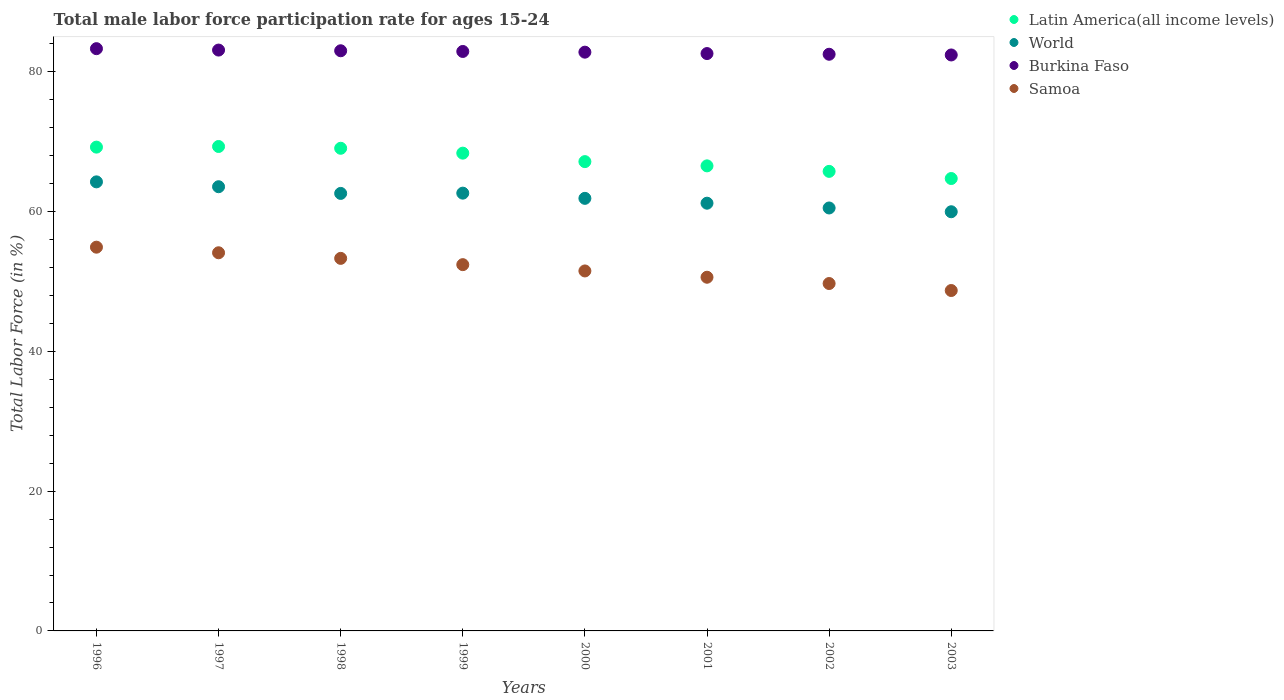How many different coloured dotlines are there?
Make the answer very short. 4. Is the number of dotlines equal to the number of legend labels?
Ensure brevity in your answer.  Yes. What is the male labor force participation rate in Burkina Faso in 2002?
Ensure brevity in your answer.  82.5. Across all years, what is the maximum male labor force participation rate in World?
Provide a succinct answer. 64.24. Across all years, what is the minimum male labor force participation rate in Samoa?
Provide a short and direct response. 48.7. In which year was the male labor force participation rate in World minimum?
Keep it short and to the point. 2003. What is the total male labor force participation rate in Latin America(all income levels) in the graph?
Ensure brevity in your answer.  540.06. What is the difference between the male labor force participation rate in World in 1999 and that in 2002?
Make the answer very short. 2.12. What is the difference between the male labor force participation rate in Samoa in 1997 and the male labor force participation rate in Latin America(all income levels) in 1999?
Offer a very short reply. -14.25. What is the average male labor force participation rate in World per year?
Your answer should be very brief. 62.07. In the year 2003, what is the difference between the male labor force participation rate in Burkina Faso and male labor force participation rate in World?
Offer a very short reply. 22.43. In how many years, is the male labor force participation rate in Burkina Faso greater than 80 %?
Ensure brevity in your answer.  8. What is the ratio of the male labor force participation rate in Burkina Faso in 1999 to that in 2001?
Make the answer very short. 1. Is the male labor force participation rate in World in 1996 less than that in 1997?
Ensure brevity in your answer.  No. What is the difference between the highest and the second highest male labor force participation rate in Burkina Faso?
Your response must be concise. 0.2. What is the difference between the highest and the lowest male labor force participation rate in Samoa?
Provide a succinct answer. 6.2. In how many years, is the male labor force participation rate in Burkina Faso greater than the average male labor force participation rate in Burkina Faso taken over all years?
Give a very brief answer. 4. Is the sum of the male labor force participation rate in Samoa in 1997 and 1999 greater than the maximum male labor force participation rate in Latin America(all income levels) across all years?
Offer a very short reply. Yes. Does the male labor force participation rate in Latin America(all income levels) monotonically increase over the years?
Offer a terse response. No. Is the male labor force participation rate in Latin America(all income levels) strictly greater than the male labor force participation rate in World over the years?
Your answer should be compact. Yes. How many dotlines are there?
Your answer should be very brief. 4. How many years are there in the graph?
Your answer should be compact. 8. Does the graph contain grids?
Offer a terse response. No. Where does the legend appear in the graph?
Your answer should be very brief. Top right. How many legend labels are there?
Offer a very short reply. 4. What is the title of the graph?
Offer a very short reply. Total male labor force participation rate for ages 15-24. Does "French Polynesia" appear as one of the legend labels in the graph?
Your answer should be compact. No. What is the label or title of the X-axis?
Offer a very short reply. Years. What is the Total Labor Force (in %) in Latin America(all income levels) in 1996?
Your answer should be compact. 69.21. What is the Total Labor Force (in %) of World in 1996?
Provide a short and direct response. 64.24. What is the Total Labor Force (in %) of Burkina Faso in 1996?
Offer a terse response. 83.3. What is the Total Labor Force (in %) in Samoa in 1996?
Offer a very short reply. 54.9. What is the Total Labor Force (in %) of Latin America(all income levels) in 1997?
Give a very brief answer. 69.31. What is the Total Labor Force (in %) in World in 1997?
Provide a short and direct response. 63.55. What is the Total Labor Force (in %) in Burkina Faso in 1997?
Give a very brief answer. 83.1. What is the Total Labor Force (in %) of Samoa in 1997?
Offer a very short reply. 54.1. What is the Total Labor Force (in %) in Latin America(all income levels) in 1998?
Give a very brief answer. 69.05. What is the Total Labor Force (in %) of World in 1998?
Offer a terse response. 62.59. What is the Total Labor Force (in %) of Samoa in 1998?
Provide a succinct answer. 53.3. What is the Total Labor Force (in %) of Latin America(all income levels) in 1999?
Make the answer very short. 68.35. What is the Total Labor Force (in %) in World in 1999?
Keep it short and to the point. 62.63. What is the Total Labor Force (in %) in Burkina Faso in 1999?
Your response must be concise. 82.9. What is the Total Labor Force (in %) of Samoa in 1999?
Give a very brief answer. 52.4. What is the Total Labor Force (in %) in Latin America(all income levels) in 2000?
Make the answer very short. 67.14. What is the Total Labor Force (in %) in World in 2000?
Your answer should be compact. 61.89. What is the Total Labor Force (in %) in Burkina Faso in 2000?
Keep it short and to the point. 82.8. What is the Total Labor Force (in %) of Samoa in 2000?
Your answer should be compact. 51.5. What is the Total Labor Force (in %) of Latin America(all income levels) in 2001?
Your answer should be compact. 66.53. What is the Total Labor Force (in %) of World in 2001?
Give a very brief answer. 61.19. What is the Total Labor Force (in %) in Burkina Faso in 2001?
Your response must be concise. 82.6. What is the Total Labor Force (in %) of Samoa in 2001?
Offer a very short reply. 50.6. What is the Total Labor Force (in %) in Latin America(all income levels) in 2002?
Your answer should be very brief. 65.75. What is the Total Labor Force (in %) of World in 2002?
Your response must be concise. 60.51. What is the Total Labor Force (in %) of Burkina Faso in 2002?
Your answer should be very brief. 82.5. What is the Total Labor Force (in %) of Samoa in 2002?
Your response must be concise. 49.7. What is the Total Labor Force (in %) of Latin America(all income levels) in 2003?
Keep it short and to the point. 64.72. What is the Total Labor Force (in %) of World in 2003?
Your answer should be compact. 59.97. What is the Total Labor Force (in %) in Burkina Faso in 2003?
Your answer should be very brief. 82.4. What is the Total Labor Force (in %) in Samoa in 2003?
Offer a terse response. 48.7. Across all years, what is the maximum Total Labor Force (in %) in Latin America(all income levels)?
Your response must be concise. 69.31. Across all years, what is the maximum Total Labor Force (in %) of World?
Your answer should be very brief. 64.24. Across all years, what is the maximum Total Labor Force (in %) in Burkina Faso?
Provide a short and direct response. 83.3. Across all years, what is the maximum Total Labor Force (in %) of Samoa?
Give a very brief answer. 54.9. Across all years, what is the minimum Total Labor Force (in %) in Latin America(all income levels)?
Give a very brief answer. 64.72. Across all years, what is the minimum Total Labor Force (in %) of World?
Provide a succinct answer. 59.97. Across all years, what is the minimum Total Labor Force (in %) in Burkina Faso?
Provide a succinct answer. 82.4. Across all years, what is the minimum Total Labor Force (in %) in Samoa?
Provide a succinct answer. 48.7. What is the total Total Labor Force (in %) in Latin America(all income levels) in the graph?
Give a very brief answer. 540.06. What is the total Total Labor Force (in %) of World in the graph?
Offer a terse response. 496.57. What is the total Total Labor Force (in %) in Burkina Faso in the graph?
Your response must be concise. 662.6. What is the total Total Labor Force (in %) in Samoa in the graph?
Make the answer very short. 415.2. What is the difference between the Total Labor Force (in %) in Latin America(all income levels) in 1996 and that in 1997?
Your answer should be very brief. -0.09. What is the difference between the Total Labor Force (in %) of World in 1996 and that in 1997?
Ensure brevity in your answer.  0.7. What is the difference between the Total Labor Force (in %) in Latin America(all income levels) in 1996 and that in 1998?
Keep it short and to the point. 0.16. What is the difference between the Total Labor Force (in %) of World in 1996 and that in 1998?
Offer a terse response. 1.65. What is the difference between the Total Labor Force (in %) of Latin America(all income levels) in 1996 and that in 1999?
Keep it short and to the point. 0.86. What is the difference between the Total Labor Force (in %) of World in 1996 and that in 1999?
Provide a short and direct response. 1.62. What is the difference between the Total Labor Force (in %) in Burkina Faso in 1996 and that in 1999?
Offer a very short reply. 0.4. What is the difference between the Total Labor Force (in %) in Samoa in 1996 and that in 1999?
Your answer should be compact. 2.5. What is the difference between the Total Labor Force (in %) in Latin America(all income levels) in 1996 and that in 2000?
Give a very brief answer. 2.07. What is the difference between the Total Labor Force (in %) in World in 1996 and that in 2000?
Your answer should be very brief. 2.36. What is the difference between the Total Labor Force (in %) in Burkina Faso in 1996 and that in 2000?
Your answer should be very brief. 0.5. What is the difference between the Total Labor Force (in %) in Samoa in 1996 and that in 2000?
Provide a succinct answer. 3.4. What is the difference between the Total Labor Force (in %) of Latin America(all income levels) in 1996 and that in 2001?
Your answer should be compact. 2.68. What is the difference between the Total Labor Force (in %) of World in 1996 and that in 2001?
Offer a terse response. 3.05. What is the difference between the Total Labor Force (in %) in Burkina Faso in 1996 and that in 2001?
Keep it short and to the point. 0.7. What is the difference between the Total Labor Force (in %) of Samoa in 1996 and that in 2001?
Offer a very short reply. 4.3. What is the difference between the Total Labor Force (in %) of Latin America(all income levels) in 1996 and that in 2002?
Offer a terse response. 3.47. What is the difference between the Total Labor Force (in %) in World in 1996 and that in 2002?
Give a very brief answer. 3.74. What is the difference between the Total Labor Force (in %) in Latin America(all income levels) in 1996 and that in 2003?
Ensure brevity in your answer.  4.49. What is the difference between the Total Labor Force (in %) in World in 1996 and that in 2003?
Provide a succinct answer. 4.28. What is the difference between the Total Labor Force (in %) of Burkina Faso in 1996 and that in 2003?
Your response must be concise. 0.9. What is the difference between the Total Labor Force (in %) of Latin America(all income levels) in 1997 and that in 1998?
Offer a very short reply. 0.26. What is the difference between the Total Labor Force (in %) of World in 1997 and that in 1998?
Make the answer very short. 0.96. What is the difference between the Total Labor Force (in %) in Burkina Faso in 1997 and that in 1998?
Keep it short and to the point. 0.1. What is the difference between the Total Labor Force (in %) of Samoa in 1997 and that in 1998?
Offer a very short reply. 0.8. What is the difference between the Total Labor Force (in %) in Latin America(all income levels) in 1997 and that in 1999?
Your answer should be very brief. 0.95. What is the difference between the Total Labor Force (in %) of World in 1997 and that in 1999?
Your answer should be compact. 0.92. What is the difference between the Total Labor Force (in %) in Burkina Faso in 1997 and that in 1999?
Provide a succinct answer. 0.2. What is the difference between the Total Labor Force (in %) of Samoa in 1997 and that in 1999?
Your response must be concise. 1.7. What is the difference between the Total Labor Force (in %) of Latin America(all income levels) in 1997 and that in 2000?
Offer a terse response. 2.16. What is the difference between the Total Labor Force (in %) of World in 1997 and that in 2000?
Provide a succinct answer. 1.66. What is the difference between the Total Labor Force (in %) in Burkina Faso in 1997 and that in 2000?
Give a very brief answer. 0.3. What is the difference between the Total Labor Force (in %) of Samoa in 1997 and that in 2000?
Your response must be concise. 2.6. What is the difference between the Total Labor Force (in %) in Latin America(all income levels) in 1997 and that in 2001?
Provide a short and direct response. 2.77. What is the difference between the Total Labor Force (in %) in World in 1997 and that in 2001?
Ensure brevity in your answer.  2.36. What is the difference between the Total Labor Force (in %) of Burkina Faso in 1997 and that in 2001?
Make the answer very short. 0.5. What is the difference between the Total Labor Force (in %) of Latin America(all income levels) in 1997 and that in 2002?
Ensure brevity in your answer.  3.56. What is the difference between the Total Labor Force (in %) of World in 1997 and that in 2002?
Provide a short and direct response. 3.04. What is the difference between the Total Labor Force (in %) of Samoa in 1997 and that in 2002?
Offer a very short reply. 4.4. What is the difference between the Total Labor Force (in %) of Latin America(all income levels) in 1997 and that in 2003?
Provide a short and direct response. 4.58. What is the difference between the Total Labor Force (in %) in World in 1997 and that in 2003?
Your response must be concise. 3.58. What is the difference between the Total Labor Force (in %) in Burkina Faso in 1997 and that in 2003?
Your answer should be compact. 0.7. What is the difference between the Total Labor Force (in %) of Samoa in 1997 and that in 2003?
Your answer should be compact. 5.4. What is the difference between the Total Labor Force (in %) in Latin America(all income levels) in 1998 and that in 1999?
Offer a very short reply. 0.7. What is the difference between the Total Labor Force (in %) of World in 1998 and that in 1999?
Ensure brevity in your answer.  -0.04. What is the difference between the Total Labor Force (in %) of Latin America(all income levels) in 1998 and that in 2000?
Make the answer very short. 1.91. What is the difference between the Total Labor Force (in %) of World in 1998 and that in 2000?
Your response must be concise. 0.71. What is the difference between the Total Labor Force (in %) of Latin America(all income levels) in 1998 and that in 2001?
Your answer should be compact. 2.52. What is the difference between the Total Labor Force (in %) of World in 1998 and that in 2001?
Provide a short and direct response. 1.4. What is the difference between the Total Labor Force (in %) in Samoa in 1998 and that in 2001?
Give a very brief answer. 2.7. What is the difference between the Total Labor Force (in %) in Latin America(all income levels) in 1998 and that in 2002?
Your answer should be very brief. 3.3. What is the difference between the Total Labor Force (in %) in World in 1998 and that in 2002?
Your answer should be compact. 2.08. What is the difference between the Total Labor Force (in %) in Burkina Faso in 1998 and that in 2002?
Your response must be concise. 0.5. What is the difference between the Total Labor Force (in %) of Latin America(all income levels) in 1998 and that in 2003?
Your answer should be very brief. 4.33. What is the difference between the Total Labor Force (in %) in World in 1998 and that in 2003?
Ensure brevity in your answer.  2.62. What is the difference between the Total Labor Force (in %) in Samoa in 1998 and that in 2003?
Your answer should be compact. 4.6. What is the difference between the Total Labor Force (in %) of Latin America(all income levels) in 1999 and that in 2000?
Your answer should be compact. 1.21. What is the difference between the Total Labor Force (in %) in World in 1999 and that in 2000?
Keep it short and to the point. 0.74. What is the difference between the Total Labor Force (in %) in Burkina Faso in 1999 and that in 2000?
Keep it short and to the point. 0.1. What is the difference between the Total Labor Force (in %) in Latin America(all income levels) in 1999 and that in 2001?
Your answer should be very brief. 1.82. What is the difference between the Total Labor Force (in %) of World in 1999 and that in 2001?
Give a very brief answer. 1.44. What is the difference between the Total Labor Force (in %) of Burkina Faso in 1999 and that in 2001?
Offer a terse response. 0.3. What is the difference between the Total Labor Force (in %) in Samoa in 1999 and that in 2001?
Provide a succinct answer. 1.8. What is the difference between the Total Labor Force (in %) of Latin America(all income levels) in 1999 and that in 2002?
Offer a very short reply. 2.61. What is the difference between the Total Labor Force (in %) of World in 1999 and that in 2002?
Keep it short and to the point. 2.12. What is the difference between the Total Labor Force (in %) of Samoa in 1999 and that in 2002?
Make the answer very short. 2.7. What is the difference between the Total Labor Force (in %) in Latin America(all income levels) in 1999 and that in 2003?
Provide a short and direct response. 3.63. What is the difference between the Total Labor Force (in %) of World in 1999 and that in 2003?
Ensure brevity in your answer.  2.66. What is the difference between the Total Labor Force (in %) of Samoa in 1999 and that in 2003?
Make the answer very short. 3.7. What is the difference between the Total Labor Force (in %) in Latin America(all income levels) in 2000 and that in 2001?
Give a very brief answer. 0.61. What is the difference between the Total Labor Force (in %) in World in 2000 and that in 2001?
Your response must be concise. 0.69. What is the difference between the Total Labor Force (in %) of Samoa in 2000 and that in 2001?
Provide a succinct answer. 0.9. What is the difference between the Total Labor Force (in %) in Latin America(all income levels) in 2000 and that in 2002?
Your response must be concise. 1.4. What is the difference between the Total Labor Force (in %) of World in 2000 and that in 2002?
Your answer should be compact. 1.38. What is the difference between the Total Labor Force (in %) in Samoa in 2000 and that in 2002?
Your response must be concise. 1.8. What is the difference between the Total Labor Force (in %) of Latin America(all income levels) in 2000 and that in 2003?
Give a very brief answer. 2.42. What is the difference between the Total Labor Force (in %) of World in 2000 and that in 2003?
Provide a succinct answer. 1.92. What is the difference between the Total Labor Force (in %) of Burkina Faso in 2000 and that in 2003?
Keep it short and to the point. 0.4. What is the difference between the Total Labor Force (in %) of Samoa in 2000 and that in 2003?
Ensure brevity in your answer.  2.8. What is the difference between the Total Labor Force (in %) of Latin America(all income levels) in 2001 and that in 2002?
Your answer should be very brief. 0.79. What is the difference between the Total Labor Force (in %) in World in 2001 and that in 2002?
Keep it short and to the point. 0.68. What is the difference between the Total Labor Force (in %) in Samoa in 2001 and that in 2002?
Give a very brief answer. 0.9. What is the difference between the Total Labor Force (in %) of Latin America(all income levels) in 2001 and that in 2003?
Offer a very short reply. 1.81. What is the difference between the Total Labor Force (in %) of World in 2001 and that in 2003?
Give a very brief answer. 1.22. What is the difference between the Total Labor Force (in %) of Latin America(all income levels) in 2002 and that in 2003?
Offer a very short reply. 1.02. What is the difference between the Total Labor Force (in %) in World in 2002 and that in 2003?
Provide a short and direct response. 0.54. What is the difference between the Total Labor Force (in %) of Burkina Faso in 2002 and that in 2003?
Offer a terse response. 0.1. What is the difference between the Total Labor Force (in %) of Latin America(all income levels) in 1996 and the Total Labor Force (in %) of World in 1997?
Offer a terse response. 5.67. What is the difference between the Total Labor Force (in %) in Latin America(all income levels) in 1996 and the Total Labor Force (in %) in Burkina Faso in 1997?
Give a very brief answer. -13.89. What is the difference between the Total Labor Force (in %) of Latin America(all income levels) in 1996 and the Total Labor Force (in %) of Samoa in 1997?
Your response must be concise. 15.11. What is the difference between the Total Labor Force (in %) in World in 1996 and the Total Labor Force (in %) in Burkina Faso in 1997?
Offer a very short reply. -18.86. What is the difference between the Total Labor Force (in %) in World in 1996 and the Total Labor Force (in %) in Samoa in 1997?
Offer a terse response. 10.14. What is the difference between the Total Labor Force (in %) in Burkina Faso in 1996 and the Total Labor Force (in %) in Samoa in 1997?
Give a very brief answer. 29.2. What is the difference between the Total Labor Force (in %) in Latin America(all income levels) in 1996 and the Total Labor Force (in %) in World in 1998?
Provide a short and direct response. 6.62. What is the difference between the Total Labor Force (in %) in Latin America(all income levels) in 1996 and the Total Labor Force (in %) in Burkina Faso in 1998?
Your response must be concise. -13.79. What is the difference between the Total Labor Force (in %) in Latin America(all income levels) in 1996 and the Total Labor Force (in %) in Samoa in 1998?
Ensure brevity in your answer.  15.91. What is the difference between the Total Labor Force (in %) of World in 1996 and the Total Labor Force (in %) of Burkina Faso in 1998?
Make the answer very short. -18.76. What is the difference between the Total Labor Force (in %) in World in 1996 and the Total Labor Force (in %) in Samoa in 1998?
Provide a succinct answer. 10.94. What is the difference between the Total Labor Force (in %) of Burkina Faso in 1996 and the Total Labor Force (in %) of Samoa in 1998?
Offer a terse response. 30. What is the difference between the Total Labor Force (in %) of Latin America(all income levels) in 1996 and the Total Labor Force (in %) of World in 1999?
Your response must be concise. 6.58. What is the difference between the Total Labor Force (in %) in Latin America(all income levels) in 1996 and the Total Labor Force (in %) in Burkina Faso in 1999?
Give a very brief answer. -13.69. What is the difference between the Total Labor Force (in %) in Latin America(all income levels) in 1996 and the Total Labor Force (in %) in Samoa in 1999?
Offer a very short reply. 16.81. What is the difference between the Total Labor Force (in %) of World in 1996 and the Total Labor Force (in %) of Burkina Faso in 1999?
Provide a succinct answer. -18.66. What is the difference between the Total Labor Force (in %) of World in 1996 and the Total Labor Force (in %) of Samoa in 1999?
Provide a succinct answer. 11.84. What is the difference between the Total Labor Force (in %) in Burkina Faso in 1996 and the Total Labor Force (in %) in Samoa in 1999?
Offer a terse response. 30.9. What is the difference between the Total Labor Force (in %) in Latin America(all income levels) in 1996 and the Total Labor Force (in %) in World in 2000?
Offer a very short reply. 7.33. What is the difference between the Total Labor Force (in %) of Latin America(all income levels) in 1996 and the Total Labor Force (in %) of Burkina Faso in 2000?
Offer a very short reply. -13.59. What is the difference between the Total Labor Force (in %) of Latin America(all income levels) in 1996 and the Total Labor Force (in %) of Samoa in 2000?
Make the answer very short. 17.71. What is the difference between the Total Labor Force (in %) of World in 1996 and the Total Labor Force (in %) of Burkina Faso in 2000?
Provide a succinct answer. -18.56. What is the difference between the Total Labor Force (in %) in World in 1996 and the Total Labor Force (in %) in Samoa in 2000?
Your answer should be compact. 12.74. What is the difference between the Total Labor Force (in %) of Burkina Faso in 1996 and the Total Labor Force (in %) of Samoa in 2000?
Your answer should be compact. 31.8. What is the difference between the Total Labor Force (in %) in Latin America(all income levels) in 1996 and the Total Labor Force (in %) in World in 2001?
Provide a short and direct response. 8.02. What is the difference between the Total Labor Force (in %) in Latin America(all income levels) in 1996 and the Total Labor Force (in %) in Burkina Faso in 2001?
Provide a succinct answer. -13.39. What is the difference between the Total Labor Force (in %) in Latin America(all income levels) in 1996 and the Total Labor Force (in %) in Samoa in 2001?
Give a very brief answer. 18.61. What is the difference between the Total Labor Force (in %) of World in 1996 and the Total Labor Force (in %) of Burkina Faso in 2001?
Keep it short and to the point. -18.36. What is the difference between the Total Labor Force (in %) of World in 1996 and the Total Labor Force (in %) of Samoa in 2001?
Offer a very short reply. 13.64. What is the difference between the Total Labor Force (in %) of Burkina Faso in 1996 and the Total Labor Force (in %) of Samoa in 2001?
Ensure brevity in your answer.  32.7. What is the difference between the Total Labor Force (in %) in Latin America(all income levels) in 1996 and the Total Labor Force (in %) in World in 2002?
Your answer should be very brief. 8.7. What is the difference between the Total Labor Force (in %) in Latin America(all income levels) in 1996 and the Total Labor Force (in %) in Burkina Faso in 2002?
Your response must be concise. -13.29. What is the difference between the Total Labor Force (in %) in Latin America(all income levels) in 1996 and the Total Labor Force (in %) in Samoa in 2002?
Provide a short and direct response. 19.51. What is the difference between the Total Labor Force (in %) of World in 1996 and the Total Labor Force (in %) of Burkina Faso in 2002?
Offer a very short reply. -18.26. What is the difference between the Total Labor Force (in %) of World in 1996 and the Total Labor Force (in %) of Samoa in 2002?
Your answer should be very brief. 14.54. What is the difference between the Total Labor Force (in %) of Burkina Faso in 1996 and the Total Labor Force (in %) of Samoa in 2002?
Your answer should be very brief. 33.6. What is the difference between the Total Labor Force (in %) of Latin America(all income levels) in 1996 and the Total Labor Force (in %) of World in 2003?
Your response must be concise. 9.25. What is the difference between the Total Labor Force (in %) in Latin America(all income levels) in 1996 and the Total Labor Force (in %) in Burkina Faso in 2003?
Your answer should be compact. -13.19. What is the difference between the Total Labor Force (in %) of Latin America(all income levels) in 1996 and the Total Labor Force (in %) of Samoa in 2003?
Ensure brevity in your answer.  20.51. What is the difference between the Total Labor Force (in %) of World in 1996 and the Total Labor Force (in %) of Burkina Faso in 2003?
Make the answer very short. -18.16. What is the difference between the Total Labor Force (in %) in World in 1996 and the Total Labor Force (in %) in Samoa in 2003?
Offer a terse response. 15.54. What is the difference between the Total Labor Force (in %) of Burkina Faso in 1996 and the Total Labor Force (in %) of Samoa in 2003?
Keep it short and to the point. 34.6. What is the difference between the Total Labor Force (in %) in Latin America(all income levels) in 1997 and the Total Labor Force (in %) in World in 1998?
Make the answer very short. 6.71. What is the difference between the Total Labor Force (in %) of Latin America(all income levels) in 1997 and the Total Labor Force (in %) of Burkina Faso in 1998?
Make the answer very short. -13.69. What is the difference between the Total Labor Force (in %) of Latin America(all income levels) in 1997 and the Total Labor Force (in %) of Samoa in 1998?
Provide a short and direct response. 16.01. What is the difference between the Total Labor Force (in %) in World in 1997 and the Total Labor Force (in %) in Burkina Faso in 1998?
Your answer should be very brief. -19.45. What is the difference between the Total Labor Force (in %) of World in 1997 and the Total Labor Force (in %) of Samoa in 1998?
Provide a succinct answer. 10.25. What is the difference between the Total Labor Force (in %) in Burkina Faso in 1997 and the Total Labor Force (in %) in Samoa in 1998?
Provide a succinct answer. 29.8. What is the difference between the Total Labor Force (in %) of Latin America(all income levels) in 1997 and the Total Labor Force (in %) of World in 1999?
Offer a very short reply. 6.68. What is the difference between the Total Labor Force (in %) of Latin America(all income levels) in 1997 and the Total Labor Force (in %) of Burkina Faso in 1999?
Offer a terse response. -13.59. What is the difference between the Total Labor Force (in %) of Latin America(all income levels) in 1997 and the Total Labor Force (in %) of Samoa in 1999?
Your answer should be very brief. 16.91. What is the difference between the Total Labor Force (in %) in World in 1997 and the Total Labor Force (in %) in Burkina Faso in 1999?
Make the answer very short. -19.35. What is the difference between the Total Labor Force (in %) of World in 1997 and the Total Labor Force (in %) of Samoa in 1999?
Your answer should be compact. 11.15. What is the difference between the Total Labor Force (in %) of Burkina Faso in 1997 and the Total Labor Force (in %) of Samoa in 1999?
Ensure brevity in your answer.  30.7. What is the difference between the Total Labor Force (in %) of Latin America(all income levels) in 1997 and the Total Labor Force (in %) of World in 2000?
Your answer should be compact. 7.42. What is the difference between the Total Labor Force (in %) of Latin America(all income levels) in 1997 and the Total Labor Force (in %) of Burkina Faso in 2000?
Offer a terse response. -13.49. What is the difference between the Total Labor Force (in %) in Latin America(all income levels) in 1997 and the Total Labor Force (in %) in Samoa in 2000?
Provide a succinct answer. 17.81. What is the difference between the Total Labor Force (in %) of World in 1997 and the Total Labor Force (in %) of Burkina Faso in 2000?
Ensure brevity in your answer.  -19.25. What is the difference between the Total Labor Force (in %) of World in 1997 and the Total Labor Force (in %) of Samoa in 2000?
Make the answer very short. 12.05. What is the difference between the Total Labor Force (in %) in Burkina Faso in 1997 and the Total Labor Force (in %) in Samoa in 2000?
Provide a short and direct response. 31.6. What is the difference between the Total Labor Force (in %) of Latin America(all income levels) in 1997 and the Total Labor Force (in %) of World in 2001?
Your answer should be compact. 8.11. What is the difference between the Total Labor Force (in %) of Latin America(all income levels) in 1997 and the Total Labor Force (in %) of Burkina Faso in 2001?
Give a very brief answer. -13.29. What is the difference between the Total Labor Force (in %) in Latin America(all income levels) in 1997 and the Total Labor Force (in %) in Samoa in 2001?
Your response must be concise. 18.71. What is the difference between the Total Labor Force (in %) in World in 1997 and the Total Labor Force (in %) in Burkina Faso in 2001?
Provide a succinct answer. -19.05. What is the difference between the Total Labor Force (in %) in World in 1997 and the Total Labor Force (in %) in Samoa in 2001?
Keep it short and to the point. 12.95. What is the difference between the Total Labor Force (in %) of Burkina Faso in 1997 and the Total Labor Force (in %) of Samoa in 2001?
Provide a short and direct response. 32.5. What is the difference between the Total Labor Force (in %) in Latin America(all income levels) in 1997 and the Total Labor Force (in %) in World in 2002?
Your response must be concise. 8.8. What is the difference between the Total Labor Force (in %) in Latin America(all income levels) in 1997 and the Total Labor Force (in %) in Burkina Faso in 2002?
Your answer should be very brief. -13.19. What is the difference between the Total Labor Force (in %) in Latin America(all income levels) in 1997 and the Total Labor Force (in %) in Samoa in 2002?
Provide a short and direct response. 19.61. What is the difference between the Total Labor Force (in %) of World in 1997 and the Total Labor Force (in %) of Burkina Faso in 2002?
Offer a very short reply. -18.95. What is the difference between the Total Labor Force (in %) in World in 1997 and the Total Labor Force (in %) in Samoa in 2002?
Offer a terse response. 13.85. What is the difference between the Total Labor Force (in %) of Burkina Faso in 1997 and the Total Labor Force (in %) of Samoa in 2002?
Your answer should be very brief. 33.4. What is the difference between the Total Labor Force (in %) in Latin America(all income levels) in 1997 and the Total Labor Force (in %) in World in 2003?
Your response must be concise. 9.34. What is the difference between the Total Labor Force (in %) in Latin America(all income levels) in 1997 and the Total Labor Force (in %) in Burkina Faso in 2003?
Keep it short and to the point. -13.09. What is the difference between the Total Labor Force (in %) in Latin America(all income levels) in 1997 and the Total Labor Force (in %) in Samoa in 2003?
Your response must be concise. 20.61. What is the difference between the Total Labor Force (in %) in World in 1997 and the Total Labor Force (in %) in Burkina Faso in 2003?
Your response must be concise. -18.85. What is the difference between the Total Labor Force (in %) in World in 1997 and the Total Labor Force (in %) in Samoa in 2003?
Offer a terse response. 14.85. What is the difference between the Total Labor Force (in %) in Burkina Faso in 1997 and the Total Labor Force (in %) in Samoa in 2003?
Ensure brevity in your answer.  34.4. What is the difference between the Total Labor Force (in %) of Latin America(all income levels) in 1998 and the Total Labor Force (in %) of World in 1999?
Provide a succinct answer. 6.42. What is the difference between the Total Labor Force (in %) in Latin America(all income levels) in 1998 and the Total Labor Force (in %) in Burkina Faso in 1999?
Offer a terse response. -13.85. What is the difference between the Total Labor Force (in %) of Latin America(all income levels) in 1998 and the Total Labor Force (in %) of Samoa in 1999?
Provide a short and direct response. 16.65. What is the difference between the Total Labor Force (in %) in World in 1998 and the Total Labor Force (in %) in Burkina Faso in 1999?
Offer a very short reply. -20.31. What is the difference between the Total Labor Force (in %) in World in 1998 and the Total Labor Force (in %) in Samoa in 1999?
Keep it short and to the point. 10.19. What is the difference between the Total Labor Force (in %) of Burkina Faso in 1998 and the Total Labor Force (in %) of Samoa in 1999?
Ensure brevity in your answer.  30.6. What is the difference between the Total Labor Force (in %) in Latin America(all income levels) in 1998 and the Total Labor Force (in %) in World in 2000?
Offer a terse response. 7.16. What is the difference between the Total Labor Force (in %) of Latin America(all income levels) in 1998 and the Total Labor Force (in %) of Burkina Faso in 2000?
Your answer should be compact. -13.75. What is the difference between the Total Labor Force (in %) in Latin America(all income levels) in 1998 and the Total Labor Force (in %) in Samoa in 2000?
Your response must be concise. 17.55. What is the difference between the Total Labor Force (in %) of World in 1998 and the Total Labor Force (in %) of Burkina Faso in 2000?
Offer a terse response. -20.21. What is the difference between the Total Labor Force (in %) in World in 1998 and the Total Labor Force (in %) in Samoa in 2000?
Provide a succinct answer. 11.09. What is the difference between the Total Labor Force (in %) in Burkina Faso in 1998 and the Total Labor Force (in %) in Samoa in 2000?
Your response must be concise. 31.5. What is the difference between the Total Labor Force (in %) in Latin America(all income levels) in 1998 and the Total Labor Force (in %) in World in 2001?
Make the answer very short. 7.86. What is the difference between the Total Labor Force (in %) in Latin America(all income levels) in 1998 and the Total Labor Force (in %) in Burkina Faso in 2001?
Your response must be concise. -13.55. What is the difference between the Total Labor Force (in %) of Latin America(all income levels) in 1998 and the Total Labor Force (in %) of Samoa in 2001?
Keep it short and to the point. 18.45. What is the difference between the Total Labor Force (in %) in World in 1998 and the Total Labor Force (in %) in Burkina Faso in 2001?
Provide a succinct answer. -20.01. What is the difference between the Total Labor Force (in %) in World in 1998 and the Total Labor Force (in %) in Samoa in 2001?
Provide a succinct answer. 11.99. What is the difference between the Total Labor Force (in %) of Burkina Faso in 1998 and the Total Labor Force (in %) of Samoa in 2001?
Give a very brief answer. 32.4. What is the difference between the Total Labor Force (in %) in Latin America(all income levels) in 1998 and the Total Labor Force (in %) in World in 2002?
Your answer should be very brief. 8.54. What is the difference between the Total Labor Force (in %) of Latin America(all income levels) in 1998 and the Total Labor Force (in %) of Burkina Faso in 2002?
Offer a terse response. -13.45. What is the difference between the Total Labor Force (in %) of Latin America(all income levels) in 1998 and the Total Labor Force (in %) of Samoa in 2002?
Give a very brief answer. 19.35. What is the difference between the Total Labor Force (in %) in World in 1998 and the Total Labor Force (in %) in Burkina Faso in 2002?
Ensure brevity in your answer.  -19.91. What is the difference between the Total Labor Force (in %) in World in 1998 and the Total Labor Force (in %) in Samoa in 2002?
Your answer should be compact. 12.89. What is the difference between the Total Labor Force (in %) in Burkina Faso in 1998 and the Total Labor Force (in %) in Samoa in 2002?
Make the answer very short. 33.3. What is the difference between the Total Labor Force (in %) in Latin America(all income levels) in 1998 and the Total Labor Force (in %) in World in 2003?
Make the answer very short. 9.08. What is the difference between the Total Labor Force (in %) of Latin America(all income levels) in 1998 and the Total Labor Force (in %) of Burkina Faso in 2003?
Provide a short and direct response. -13.35. What is the difference between the Total Labor Force (in %) in Latin America(all income levels) in 1998 and the Total Labor Force (in %) in Samoa in 2003?
Provide a short and direct response. 20.35. What is the difference between the Total Labor Force (in %) of World in 1998 and the Total Labor Force (in %) of Burkina Faso in 2003?
Make the answer very short. -19.81. What is the difference between the Total Labor Force (in %) of World in 1998 and the Total Labor Force (in %) of Samoa in 2003?
Offer a very short reply. 13.89. What is the difference between the Total Labor Force (in %) of Burkina Faso in 1998 and the Total Labor Force (in %) of Samoa in 2003?
Make the answer very short. 34.3. What is the difference between the Total Labor Force (in %) in Latin America(all income levels) in 1999 and the Total Labor Force (in %) in World in 2000?
Keep it short and to the point. 6.47. What is the difference between the Total Labor Force (in %) in Latin America(all income levels) in 1999 and the Total Labor Force (in %) in Burkina Faso in 2000?
Keep it short and to the point. -14.45. What is the difference between the Total Labor Force (in %) in Latin America(all income levels) in 1999 and the Total Labor Force (in %) in Samoa in 2000?
Provide a short and direct response. 16.85. What is the difference between the Total Labor Force (in %) in World in 1999 and the Total Labor Force (in %) in Burkina Faso in 2000?
Provide a succinct answer. -20.17. What is the difference between the Total Labor Force (in %) in World in 1999 and the Total Labor Force (in %) in Samoa in 2000?
Provide a succinct answer. 11.13. What is the difference between the Total Labor Force (in %) in Burkina Faso in 1999 and the Total Labor Force (in %) in Samoa in 2000?
Offer a terse response. 31.4. What is the difference between the Total Labor Force (in %) in Latin America(all income levels) in 1999 and the Total Labor Force (in %) in World in 2001?
Offer a terse response. 7.16. What is the difference between the Total Labor Force (in %) of Latin America(all income levels) in 1999 and the Total Labor Force (in %) of Burkina Faso in 2001?
Give a very brief answer. -14.25. What is the difference between the Total Labor Force (in %) of Latin America(all income levels) in 1999 and the Total Labor Force (in %) of Samoa in 2001?
Provide a succinct answer. 17.75. What is the difference between the Total Labor Force (in %) in World in 1999 and the Total Labor Force (in %) in Burkina Faso in 2001?
Your answer should be very brief. -19.97. What is the difference between the Total Labor Force (in %) in World in 1999 and the Total Labor Force (in %) in Samoa in 2001?
Ensure brevity in your answer.  12.03. What is the difference between the Total Labor Force (in %) in Burkina Faso in 1999 and the Total Labor Force (in %) in Samoa in 2001?
Provide a short and direct response. 32.3. What is the difference between the Total Labor Force (in %) in Latin America(all income levels) in 1999 and the Total Labor Force (in %) in World in 2002?
Provide a short and direct response. 7.84. What is the difference between the Total Labor Force (in %) of Latin America(all income levels) in 1999 and the Total Labor Force (in %) of Burkina Faso in 2002?
Ensure brevity in your answer.  -14.15. What is the difference between the Total Labor Force (in %) in Latin America(all income levels) in 1999 and the Total Labor Force (in %) in Samoa in 2002?
Offer a terse response. 18.65. What is the difference between the Total Labor Force (in %) in World in 1999 and the Total Labor Force (in %) in Burkina Faso in 2002?
Give a very brief answer. -19.87. What is the difference between the Total Labor Force (in %) of World in 1999 and the Total Labor Force (in %) of Samoa in 2002?
Keep it short and to the point. 12.93. What is the difference between the Total Labor Force (in %) in Burkina Faso in 1999 and the Total Labor Force (in %) in Samoa in 2002?
Provide a succinct answer. 33.2. What is the difference between the Total Labor Force (in %) in Latin America(all income levels) in 1999 and the Total Labor Force (in %) in World in 2003?
Your answer should be very brief. 8.38. What is the difference between the Total Labor Force (in %) of Latin America(all income levels) in 1999 and the Total Labor Force (in %) of Burkina Faso in 2003?
Your answer should be very brief. -14.05. What is the difference between the Total Labor Force (in %) in Latin America(all income levels) in 1999 and the Total Labor Force (in %) in Samoa in 2003?
Provide a short and direct response. 19.65. What is the difference between the Total Labor Force (in %) of World in 1999 and the Total Labor Force (in %) of Burkina Faso in 2003?
Ensure brevity in your answer.  -19.77. What is the difference between the Total Labor Force (in %) of World in 1999 and the Total Labor Force (in %) of Samoa in 2003?
Ensure brevity in your answer.  13.93. What is the difference between the Total Labor Force (in %) of Burkina Faso in 1999 and the Total Labor Force (in %) of Samoa in 2003?
Offer a very short reply. 34.2. What is the difference between the Total Labor Force (in %) of Latin America(all income levels) in 2000 and the Total Labor Force (in %) of World in 2001?
Offer a very short reply. 5.95. What is the difference between the Total Labor Force (in %) in Latin America(all income levels) in 2000 and the Total Labor Force (in %) in Burkina Faso in 2001?
Your answer should be compact. -15.46. What is the difference between the Total Labor Force (in %) in Latin America(all income levels) in 2000 and the Total Labor Force (in %) in Samoa in 2001?
Provide a succinct answer. 16.54. What is the difference between the Total Labor Force (in %) in World in 2000 and the Total Labor Force (in %) in Burkina Faso in 2001?
Make the answer very short. -20.71. What is the difference between the Total Labor Force (in %) in World in 2000 and the Total Labor Force (in %) in Samoa in 2001?
Offer a very short reply. 11.29. What is the difference between the Total Labor Force (in %) in Burkina Faso in 2000 and the Total Labor Force (in %) in Samoa in 2001?
Ensure brevity in your answer.  32.2. What is the difference between the Total Labor Force (in %) of Latin America(all income levels) in 2000 and the Total Labor Force (in %) of World in 2002?
Your answer should be very brief. 6.63. What is the difference between the Total Labor Force (in %) of Latin America(all income levels) in 2000 and the Total Labor Force (in %) of Burkina Faso in 2002?
Your response must be concise. -15.36. What is the difference between the Total Labor Force (in %) of Latin America(all income levels) in 2000 and the Total Labor Force (in %) of Samoa in 2002?
Give a very brief answer. 17.44. What is the difference between the Total Labor Force (in %) of World in 2000 and the Total Labor Force (in %) of Burkina Faso in 2002?
Ensure brevity in your answer.  -20.61. What is the difference between the Total Labor Force (in %) of World in 2000 and the Total Labor Force (in %) of Samoa in 2002?
Give a very brief answer. 12.19. What is the difference between the Total Labor Force (in %) of Burkina Faso in 2000 and the Total Labor Force (in %) of Samoa in 2002?
Make the answer very short. 33.1. What is the difference between the Total Labor Force (in %) in Latin America(all income levels) in 2000 and the Total Labor Force (in %) in World in 2003?
Provide a succinct answer. 7.17. What is the difference between the Total Labor Force (in %) of Latin America(all income levels) in 2000 and the Total Labor Force (in %) of Burkina Faso in 2003?
Make the answer very short. -15.26. What is the difference between the Total Labor Force (in %) in Latin America(all income levels) in 2000 and the Total Labor Force (in %) in Samoa in 2003?
Provide a short and direct response. 18.44. What is the difference between the Total Labor Force (in %) of World in 2000 and the Total Labor Force (in %) of Burkina Faso in 2003?
Give a very brief answer. -20.51. What is the difference between the Total Labor Force (in %) in World in 2000 and the Total Labor Force (in %) in Samoa in 2003?
Provide a succinct answer. 13.19. What is the difference between the Total Labor Force (in %) in Burkina Faso in 2000 and the Total Labor Force (in %) in Samoa in 2003?
Make the answer very short. 34.1. What is the difference between the Total Labor Force (in %) of Latin America(all income levels) in 2001 and the Total Labor Force (in %) of World in 2002?
Provide a short and direct response. 6.02. What is the difference between the Total Labor Force (in %) in Latin America(all income levels) in 2001 and the Total Labor Force (in %) in Burkina Faso in 2002?
Your response must be concise. -15.97. What is the difference between the Total Labor Force (in %) in Latin America(all income levels) in 2001 and the Total Labor Force (in %) in Samoa in 2002?
Offer a very short reply. 16.83. What is the difference between the Total Labor Force (in %) in World in 2001 and the Total Labor Force (in %) in Burkina Faso in 2002?
Keep it short and to the point. -21.31. What is the difference between the Total Labor Force (in %) in World in 2001 and the Total Labor Force (in %) in Samoa in 2002?
Give a very brief answer. 11.49. What is the difference between the Total Labor Force (in %) of Burkina Faso in 2001 and the Total Labor Force (in %) of Samoa in 2002?
Your response must be concise. 32.9. What is the difference between the Total Labor Force (in %) of Latin America(all income levels) in 2001 and the Total Labor Force (in %) of World in 2003?
Offer a very short reply. 6.56. What is the difference between the Total Labor Force (in %) of Latin America(all income levels) in 2001 and the Total Labor Force (in %) of Burkina Faso in 2003?
Keep it short and to the point. -15.87. What is the difference between the Total Labor Force (in %) of Latin America(all income levels) in 2001 and the Total Labor Force (in %) of Samoa in 2003?
Offer a very short reply. 17.83. What is the difference between the Total Labor Force (in %) in World in 2001 and the Total Labor Force (in %) in Burkina Faso in 2003?
Offer a very short reply. -21.21. What is the difference between the Total Labor Force (in %) in World in 2001 and the Total Labor Force (in %) in Samoa in 2003?
Provide a succinct answer. 12.49. What is the difference between the Total Labor Force (in %) in Burkina Faso in 2001 and the Total Labor Force (in %) in Samoa in 2003?
Provide a succinct answer. 33.9. What is the difference between the Total Labor Force (in %) of Latin America(all income levels) in 2002 and the Total Labor Force (in %) of World in 2003?
Your answer should be very brief. 5.78. What is the difference between the Total Labor Force (in %) in Latin America(all income levels) in 2002 and the Total Labor Force (in %) in Burkina Faso in 2003?
Your answer should be very brief. -16.65. What is the difference between the Total Labor Force (in %) of Latin America(all income levels) in 2002 and the Total Labor Force (in %) of Samoa in 2003?
Keep it short and to the point. 17.05. What is the difference between the Total Labor Force (in %) of World in 2002 and the Total Labor Force (in %) of Burkina Faso in 2003?
Your answer should be compact. -21.89. What is the difference between the Total Labor Force (in %) of World in 2002 and the Total Labor Force (in %) of Samoa in 2003?
Your response must be concise. 11.81. What is the difference between the Total Labor Force (in %) of Burkina Faso in 2002 and the Total Labor Force (in %) of Samoa in 2003?
Your answer should be very brief. 33.8. What is the average Total Labor Force (in %) in Latin America(all income levels) per year?
Offer a very short reply. 67.51. What is the average Total Labor Force (in %) of World per year?
Offer a terse response. 62.07. What is the average Total Labor Force (in %) in Burkina Faso per year?
Keep it short and to the point. 82.83. What is the average Total Labor Force (in %) of Samoa per year?
Your response must be concise. 51.9. In the year 1996, what is the difference between the Total Labor Force (in %) in Latin America(all income levels) and Total Labor Force (in %) in World?
Offer a very short reply. 4.97. In the year 1996, what is the difference between the Total Labor Force (in %) in Latin America(all income levels) and Total Labor Force (in %) in Burkina Faso?
Your answer should be compact. -14.09. In the year 1996, what is the difference between the Total Labor Force (in %) of Latin America(all income levels) and Total Labor Force (in %) of Samoa?
Your response must be concise. 14.31. In the year 1996, what is the difference between the Total Labor Force (in %) of World and Total Labor Force (in %) of Burkina Faso?
Keep it short and to the point. -19.06. In the year 1996, what is the difference between the Total Labor Force (in %) in World and Total Labor Force (in %) in Samoa?
Keep it short and to the point. 9.34. In the year 1996, what is the difference between the Total Labor Force (in %) in Burkina Faso and Total Labor Force (in %) in Samoa?
Ensure brevity in your answer.  28.4. In the year 1997, what is the difference between the Total Labor Force (in %) of Latin America(all income levels) and Total Labor Force (in %) of World?
Offer a terse response. 5.76. In the year 1997, what is the difference between the Total Labor Force (in %) of Latin America(all income levels) and Total Labor Force (in %) of Burkina Faso?
Your answer should be very brief. -13.79. In the year 1997, what is the difference between the Total Labor Force (in %) in Latin America(all income levels) and Total Labor Force (in %) in Samoa?
Ensure brevity in your answer.  15.21. In the year 1997, what is the difference between the Total Labor Force (in %) of World and Total Labor Force (in %) of Burkina Faso?
Ensure brevity in your answer.  -19.55. In the year 1997, what is the difference between the Total Labor Force (in %) in World and Total Labor Force (in %) in Samoa?
Ensure brevity in your answer.  9.45. In the year 1997, what is the difference between the Total Labor Force (in %) of Burkina Faso and Total Labor Force (in %) of Samoa?
Your response must be concise. 29. In the year 1998, what is the difference between the Total Labor Force (in %) in Latin America(all income levels) and Total Labor Force (in %) in World?
Your answer should be very brief. 6.46. In the year 1998, what is the difference between the Total Labor Force (in %) of Latin America(all income levels) and Total Labor Force (in %) of Burkina Faso?
Provide a succinct answer. -13.95. In the year 1998, what is the difference between the Total Labor Force (in %) in Latin America(all income levels) and Total Labor Force (in %) in Samoa?
Your answer should be compact. 15.75. In the year 1998, what is the difference between the Total Labor Force (in %) in World and Total Labor Force (in %) in Burkina Faso?
Your answer should be compact. -20.41. In the year 1998, what is the difference between the Total Labor Force (in %) in World and Total Labor Force (in %) in Samoa?
Your answer should be compact. 9.29. In the year 1998, what is the difference between the Total Labor Force (in %) of Burkina Faso and Total Labor Force (in %) of Samoa?
Offer a very short reply. 29.7. In the year 1999, what is the difference between the Total Labor Force (in %) of Latin America(all income levels) and Total Labor Force (in %) of World?
Your answer should be compact. 5.72. In the year 1999, what is the difference between the Total Labor Force (in %) of Latin America(all income levels) and Total Labor Force (in %) of Burkina Faso?
Your response must be concise. -14.55. In the year 1999, what is the difference between the Total Labor Force (in %) of Latin America(all income levels) and Total Labor Force (in %) of Samoa?
Your answer should be very brief. 15.95. In the year 1999, what is the difference between the Total Labor Force (in %) of World and Total Labor Force (in %) of Burkina Faso?
Keep it short and to the point. -20.27. In the year 1999, what is the difference between the Total Labor Force (in %) of World and Total Labor Force (in %) of Samoa?
Your answer should be very brief. 10.23. In the year 1999, what is the difference between the Total Labor Force (in %) in Burkina Faso and Total Labor Force (in %) in Samoa?
Offer a very short reply. 30.5. In the year 2000, what is the difference between the Total Labor Force (in %) of Latin America(all income levels) and Total Labor Force (in %) of World?
Your response must be concise. 5.25. In the year 2000, what is the difference between the Total Labor Force (in %) of Latin America(all income levels) and Total Labor Force (in %) of Burkina Faso?
Provide a short and direct response. -15.66. In the year 2000, what is the difference between the Total Labor Force (in %) of Latin America(all income levels) and Total Labor Force (in %) of Samoa?
Your answer should be compact. 15.64. In the year 2000, what is the difference between the Total Labor Force (in %) of World and Total Labor Force (in %) of Burkina Faso?
Your answer should be compact. -20.91. In the year 2000, what is the difference between the Total Labor Force (in %) of World and Total Labor Force (in %) of Samoa?
Provide a short and direct response. 10.39. In the year 2000, what is the difference between the Total Labor Force (in %) in Burkina Faso and Total Labor Force (in %) in Samoa?
Your answer should be compact. 31.3. In the year 2001, what is the difference between the Total Labor Force (in %) of Latin America(all income levels) and Total Labor Force (in %) of World?
Offer a very short reply. 5.34. In the year 2001, what is the difference between the Total Labor Force (in %) of Latin America(all income levels) and Total Labor Force (in %) of Burkina Faso?
Ensure brevity in your answer.  -16.07. In the year 2001, what is the difference between the Total Labor Force (in %) of Latin America(all income levels) and Total Labor Force (in %) of Samoa?
Offer a very short reply. 15.93. In the year 2001, what is the difference between the Total Labor Force (in %) of World and Total Labor Force (in %) of Burkina Faso?
Offer a terse response. -21.41. In the year 2001, what is the difference between the Total Labor Force (in %) of World and Total Labor Force (in %) of Samoa?
Your answer should be very brief. 10.59. In the year 2001, what is the difference between the Total Labor Force (in %) in Burkina Faso and Total Labor Force (in %) in Samoa?
Give a very brief answer. 32. In the year 2002, what is the difference between the Total Labor Force (in %) in Latin America(all income levels) and Total Labor Force (in %) in World?
Provide a short and direct response. 5.24. In the year 2002, what is the difference between the Total Labor Force (in %) of Latin America(all income levels) and Total Labor Force (in %) of Burkina Faso?
Provide a succinct answer. -16.75. In the year 2002, what is the difference between the Total Labor Force (in %) of Latin America(all income levels) and Total Labor Force (in %) of Samoa?
Ensure brevity in your answer.  16.05. In the year 2002, what is the difference between the Total Labor Force (in %) in World and Total Labor Force (in %) in Burkina Faso?
Provide a short and direct response. -21.99. In the year 2002, what is the difference between the Total Labor Force (in %) in World and Total Labor Force (in %) in Samoa?
Offer a very short reply. 10.81. In the year 2002, what is the difference between the Total Labor Force (in %) in Burkina Faso and Total Labor Force (in %) in Samoa?
Your answer should be very brief. 32.8. In the year 2003, what is the difference between the Total Labor Force (in %) in Latin America(all income levels) and Total Labor Force (in %) in World?
Give a very brief answer. 4.75. In the year 2003, what is the difference between the Total Labor Force (in %) of Latin America(all income levels) and Total Labor Force (in %) of Burkina Faso?
Make the answer very short. -17.68. In the year 2003, what is the difference between the Total Labor Force (in %) of Latin America(all income levels) and Total Labor Force (in %) of Samoa?
Your answer should be very brief. 16.02. In the year 2003, what is the difference between the Total Labor Force (in %) in World and Total Labor Force (in %) in Burkina Faso?
Ensure brevity in your answer.  -22.43. In the year 2003, what is the difference between the Total Labor Force (in %) in World and Total Labor Force (in %) in Samoa?
Ensure brevity in your answer.  11.27. In the year 2003, what is the difference between the Total Labor Force (in %) of Burkina Faso and Total Labor Force (in %) of Samoa?
Your answer should be very brief. 33.7. What is the ratio of the Total Labor Force (in %) of World in 1996 to that in 1997?
Your answer should be compact. 1.01. What is the ratio of the Total Labor Force (in %) of Burkina Faso in 1996 to that in 1997?
Provide a succinct answer. 1. What is the ratio of the Total Labor Force (in %) of Samoa in 1996 to that in 1997?
Keep it short and to the point. 1.01. What is the ratio of the Total Labor Force (in %) in Latin America(all income levels) in 1996 to that in 1998?
Your answer should be very brief. 1. What is the ratio of the Total Labor Force (in %) of World in 1996 to that in 1998?
Provide a short and direct response. 1.03. What is the ratio of the Total Labor Force (in %) of Burkina Faso in 1996 to that in 1998?
Keep it short and to the point. 1. What is the ratio of the Total Labor Force (in %) of Latin America(all income levels) in 1996 to that in 1999?
Provide a short and direct response. 1.01. What is the ratio of the Total Labor Force (in %) in World in 1996 to that in 1999?
Offer a very short reply. 1.03. What is the ratio of the Total Labor Force (in %) in Burkina Faso in 1996 to that in 1999?
Provide a succinct answer. 1. What is the ratio of the Total Labor Force (in %) of Samoa in 1996 to that in 1999?
Offer a terse response. 1.05. What is the ratio of the Total Labor Force (in %) in Latin America(all income levels) in 1996 to that in 2000?
Make the answer very short. 1.03. What is the ratio of the Total Labor Force (in %) of World in 1996 to that in 2000?
Offer a terse response. 1.04. What is the ratio of the Total Labor Force (in %) of Samoa in 1996 to that in 2000?
Make the answer very short. 1.07. What is the ratio of the Total Labor Force (in %) in Latin America(all income levels) in 1996 to that in 2001?
Provide a succinct answer. 1.04. What is the ratio of the Total Labor Force (in %) of World in 1996 to that in 2001?
Offer a terse response. 1.05. What is the ratio of the Total Labor Force (in %) in Burkina Faso in 1996 to that in 2001?
Your answer should be compact. 1.01. What is the ratio of the Total Labor Force (in %) of Samoa in 1996 to that in 2001?
Offer a terse response. 1.08. What is the ratio of the Total Labor Force (in %) in Latin America(all income levels) in 1996 to that in 2002?
Offer a terse response. 1.05. What is the ratio of the Total Labor Force (in %) in World in 1996 to that in 2002?
Offer a terse response. 1.06. What is the ratio of the Total Labor Force (in %) of Burkina Faso in 1996 to that in 2002?
Your response must be concise. 1.01. What is the ratio of the Total Labor Force (in %) in Samoa in 1996 to that in 2002?
Offer a terse response. 1.1. What is the ratio of the Total Labor Force (in %) in Latin America(all income levels) in 1996 to that in 2003?
Give a very brief answer. 1.07. What is the ratio of the Total Labor Force (in %) in World in 1996 to that in 2003?
Make the answer very short. 1.07. What is the ratio of the Total Labor Force (in %) in Burkina Faso in 1996 to that in 2003?
Provide a short and direct response. 1.01. What is the ratio of the Total Labor Force (in %) of Samoa in 1996 to that in 2003?
Keep it short and to the point. 1.13. What is the ratio of the Total Labor Force (in %) of Latin America(all income levels) in 1997 to that in 1998?
Offer a very short reply. 1. What is the ratio of the Total Labor Force (in %) in World in 1997 to that in 1998?
Your answer should be compact. 1.02. What is the ratio of the Total Labor Force (in %) in Samoa in 1997 to that in 1998?
Offer a terse response. 1.01. What is the ratio of the Total Labor Force (in %) of Latin America(all income levels) in 1997 to that in 1999?
Make the answer very short. 1.01. What is the ratio of the Total Labor Force (in %) in World in 1997 to that in 1999?
Provide a succinct answer. 1.01. What is the ratio of the Total Labor Force (in %) in Burkina Faso in 1997 to that in 1999?
Give a very brief answer. 1. What is the ratio of the Total Labor Force (in %) of Samoa in 1997 to that in 1999?
Make the answer very short. 1.03. What is the ratio of the Total Labor Force (in %) in Latin America(all income levels) in 1997 to that in 2000?
Provide a short and direct response. 1.03. What is the ratio of the Total Labor Force (in %) in World in 1997 to that in 2000?
Your answer should be very brief. 1.03. What is the ratio of the Total Labor Force (in %) of Samoa in 1997 to that in 2000?
Ensure brevity in your answer.  1.05. What is the ratio of the Total Labor Force (in %) in Latin America(all income levels) in 1997 to that in 2001?
Your response must be concise. 1.04. What is the ratio of the Total Labor Force (in %) of Burkina Faso in 1997 to that in 2001?
Your answer should be very brief. 1.01. What is the ratio of the Total Labor Force (in %) of Samoa in 1997 to that in 2001?
Offer a terse response. 1.07. What is the ratio of the Total Labor Force (in %) in Latin America(all income levels) in 1997 to that in 2002?
Keep it short and to the point. 1.05. What is the ratio of the Total Labor Force (in %) of World in 1997 to that in 2002?
Provide a succinct answer. 1.05. What is the ratio of the Total Labor Force (in %) of Burkina Faso in 1997 to that in 2002?
Ensure brevity in your answer.  1.01. What is the ratio of the Total Labor Force (in %) in Samoa in 1997 to that in 2002?
Give a very brief answer. 1.09. What is the ratio of the Total Labor Force (in %) of Latin America(all income levels) in 1997 to that in 2003?
Keep it short and to the point. 1.07. What is the ratio of the Total Labor Force (in %) in World in 1997 to that in 2003?
Offer a terse response. 1.06. What is the ratio of the Total Labor Force (in %) in Burkina Faso in 1997 to that in 2003?
Ensure brevity in your answer.  1.01. What is the ratio of the Total Labor Force (in %) in Samoa in 1997 to that in 2003?
Give a very brief answer. 1.11. What is the ratio of the Total Labor Force (in %) of Latin America(all income levels) in 1998 to that in 1999?
Offer a terse response. 1.01. What is the ratio of the Total Labor Force (in %) in Burkina Faso in 1998 to that in 1999?
Your answer should be compact. 1. What is the ratio of the Total Labor Force (in %) in Samoa in 1998 to that in 1999?
Offer a very short reply. 1.02. What is the ratio of the Total Labor Force (in %) of Latin America(all income levels) in 1998 to that in 2000?
Keep it short and to the point. 1.03. What is the ratio of the Total Labor Force (in %) of World in 1998 to that in 2000?
Provide a succinct answer. 1.01. What is the ratio of the Total Labor Force (in %) in Burkina Faso in 1998 to that in 2000?
Ensure brevity in your answer.  1. What is the ratio of the Total Labor Force (in %) of Samoa in 1998 to that in 2000?
Make the answer very short. 1.03. What is the ratio of the Total Labor Force (in %) of Latin America(all income levels) in 1998 to that in 2001?
Ensure brevity in your answer.  1.04. What is the ratio of the Total Labor Force (in %) of World in 1998 to that in 2001?
Ensure brevity in your answer.  1.02. What is the ratio of the Total Labor Force (in %) in Samoa in 1998 to that in 2001?
Provide a succinct answer. 1.05. What is the ratio of the Total Labor Force (in %) of Latin America(all income levels) in 1998 to that in 2002?
Your response must be concise. 1.05. What is the ratio of the Total Labor Force (in %) of World in 1998 to that in 2002?
Offer a very short reply. 1.03. What is the ratio of the Total Labor Force (in %) in Samoa in 1998 to that in 2002?
Give a very brief answer. 1.07. What is the ratio of the Total Labor Force (in %) in Latin America(all income levels) in 1998 to that in 2003?
Your response must be concise. 1.07. What is the ratio of the Total Labor Force (in %) in World in 1998 to that in 2003?
Provide a short and direct response. 1.04. What is the ratio of the Total Labor Force (in %) in Burkina Faso in 1998 to that in 2003?
Offer a very short reply. 1.01. What is the ratio of the Total Labor Force (in %) of Samoa in 1998 to that in 2003?
Give a very brief answer. 1.09. What is the ratio of the Total Labor Force (in %) of Latin America(all income levels) in 1999 to that in 2000?
Ensure brevity in your answer.  1.02. What is the ratio of the Total Labor Force (in %) of Burkina Faso in 1999 to that in 2000?
Provide a short and direct response. 1. What is the ratio of the Total Labor Force (in %) in Samoa in 1999 to that in 2000?
Make the answer very short. 1.02. What is the ratio of the Total Labor Force (in %) in Latin America(all income levels) in 1999 to that in 2001?
Give a very brief answer. 1.03. What is the ratio of the Total Labor Force (in %) of World in 1999 to that in 2001?
Ensure brevity in your answer.  1.02. What is the ratio of the Total Labor Force (in %) of Samoa in 1999 to that in 2001?
Keep it short and to the point. 1.04. What is the ratio of the Total Labor Force (in %) of Latin America(all income levels) in 1999 to that in 2002?
Make the answer very short. 1.04. What is the ratio of the Total Labor Force (in %) of World in 1999 to that in 2002?
Provide a succinct answer. 1.03. What is the ratio of the Total Labor Force (in %) in Burkina Faso in 1999 to that in 2002?
Provide a short and direct response. 1. What is the ratio of the Total Labor Force (in %) in Samoa in 1999 to that in 2002?
Offer a terse response. 1.05. What is the ratio of the Total Labor Force (in %) of Latin America(all income levels) in 1999 to that in 2003?
Keep it short and to the point. 1.06. What is the ratio of the Total Labor Force (in %) of World in 1999 to that in 2003?
Provide a succinct answer. 1.04. What is the ratio of the Total Labor Force (in %) of Samoa in 1999 to that in 2003?
Your answer should be very brief. 1.08. What is the ratio of the Total Labor Force (in %) in Latin America(all income levels) in 2000 to that in 2001?
Make the answer very short. 1.01. What is the ratio of the Total Labor Force (in %) in World in 2000 to that in 2001?
Keep it short and to the point. 1.01. What is the ratio of the Total Labor Force (in %) of Burkina Faso in 2000 to that in 2001?
Provide a short and direct response. 1. What is the ratio of the Total Labor Force (in %) in Samoa in 2000 to that in 2001?
Provide a succinct answer. 1.02. What is the ratio of the Total Labor Force (in %) of Latin America(all income levels) in 2000 to that in 2002?
Your answer should be compact. 1.02. What is the ratio of the Total Labor Force (in %) of World in 2000 to that in 2002?
Ensure brevity in your answer.  1.02. What is the ratio of the Total Labor Force (in %) in Burkina Faso in 2000 to that in 2002?
Make the answer very short. 1. What is the ratio of the Total Labor Force (in %) in Samoa in 2000 to that in 2002?
Offer a terse response. 1.04. What is the ratio of the Total Labor Force (in %) in Latin America(all income levels) in 2000 to that in 2003?
Offer a terse response. 1.04. What is the ratio of the Total Labor Force (in %) in World in 2000 to that in 2003?
Give a very brief answer. 1.03. What is the ratio of the Total Labor Force (in %) of Burkina Faso in 2000 to that in 2003?
Keep it short and to the point. 1. What is the ratio of the Total Labor Force (in %) in Samoa in 2000 to that in 2003?
Offer a very short reply. 1.06. What is the ratio of the Total Labor Force (in %) in World in 2001 to that in 2002?
Your answer should be compact. 1.01. What is the ratio of the Total Labor Force (in %) in Samoa in 2001 to that in 2002?
Offer a terse response. 1.02. What is the ratio of the Total Labor Force (in %) in Latin America(all income levels) in 2001 to that in 2003?
Ensure brevity in your answer.  1.03. What is the ratio of the Total Labor Force (in %) in World in 2001 to that in 2003?
Provide a short and direct response. 1.02. What is the ratio of the Total Labor Force (in %) of Samoa in 2001 to that in 2003?
Offer a terse response. 1.04. What is the ratio of the Total Labor Force (in %) of Latin America(all income levels) in 2002 to that in 2003?
Make the answer very short. 1.02. What is the ratio of the Total Labor Force (in %) in Burkina Faso in 2002 to that in 2003?
Offer a terse response. 1. What is the ratio of the Total Labor Force (in %) of Samoa in 2002 to that in 2003?
Your answer should be very brief. 1.02. What is the difference between the highest and the second highest Total Labor Force (in %) in Latin America(all income levels)?
Keep it short and to the point. 0.09. What is the difference between the highest and the second highest Total Labor Force (in %) in World?
Keep it short and to the point. 0.7. What is the difference between the highest and the second highest Total Labor Force (in %) in Burkina Faso?
Keep it short and to the point. 0.2. What is the difference between the highest and the second highest Total Labor Force (in %) in Samoa?
Keep it short and to the point. 0.8. What is the difference between the highest and the lowest Total Labor Force (in %) of Latin America(all income levels)?
Ensure brevity in your answer.  4.58. What is the difference between the highest and the lowest Total Labor Force (in %) of World?
Your answer should be very brief. 4.28. What is the difference between the highest and the lowest Total Labor Force (in %) of Burkina Faso?
Your answer should be compact. 0.9. 